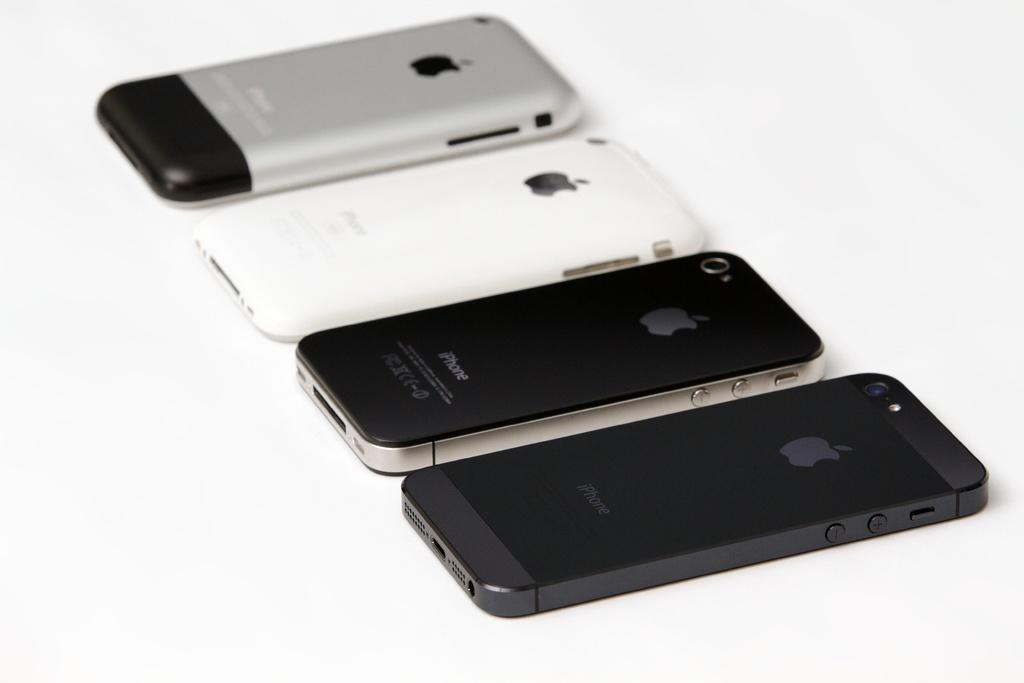<image>
Create a compact narrative representing the image presented. Four different Apple iPhones are placed in a line. 